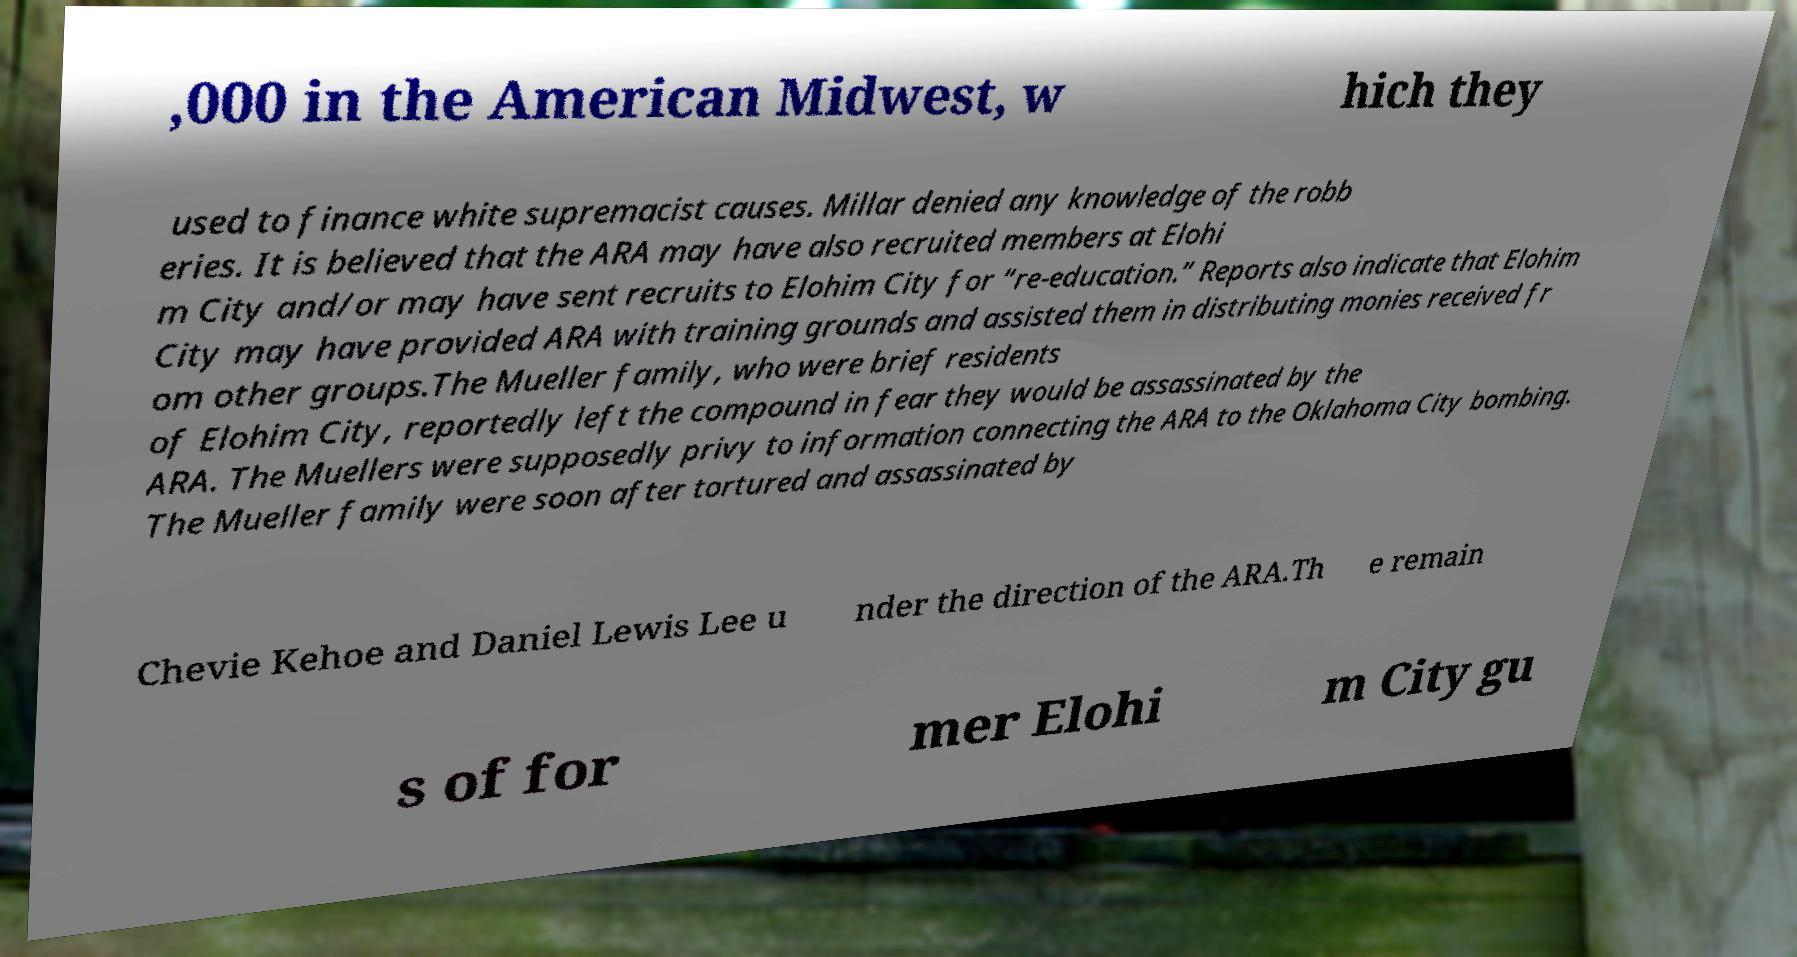For documentation purposes, I need the text within this image transcribed. Could you provide that? ,000 in the American Midwest, w hich they used to finance white supremacist causes. Millar denied any knowledge of the robb eries. It is believed that the ARA may have also recruited members at Elohi m City and/or may have sent recruits to Elohim City for “re-education.” Reports also indicate that Elohim City may have provided ARA with training grounds and assisted them in distributing monies received fr om other groups.The Mueller family, who were brief residents of Elohim City, reportedly left the compound in fear they would be assassinated by the ARA. The Muellers were supposedly privy to information connecting the ARA to the Oklahoma City bombing. The Mueller family were soon after tortured and assassinated by Chevie Kehoe and Daniel Lewis Lee u nder the direction of the ARA.Th e remain s of for mer Elohi m City gu 